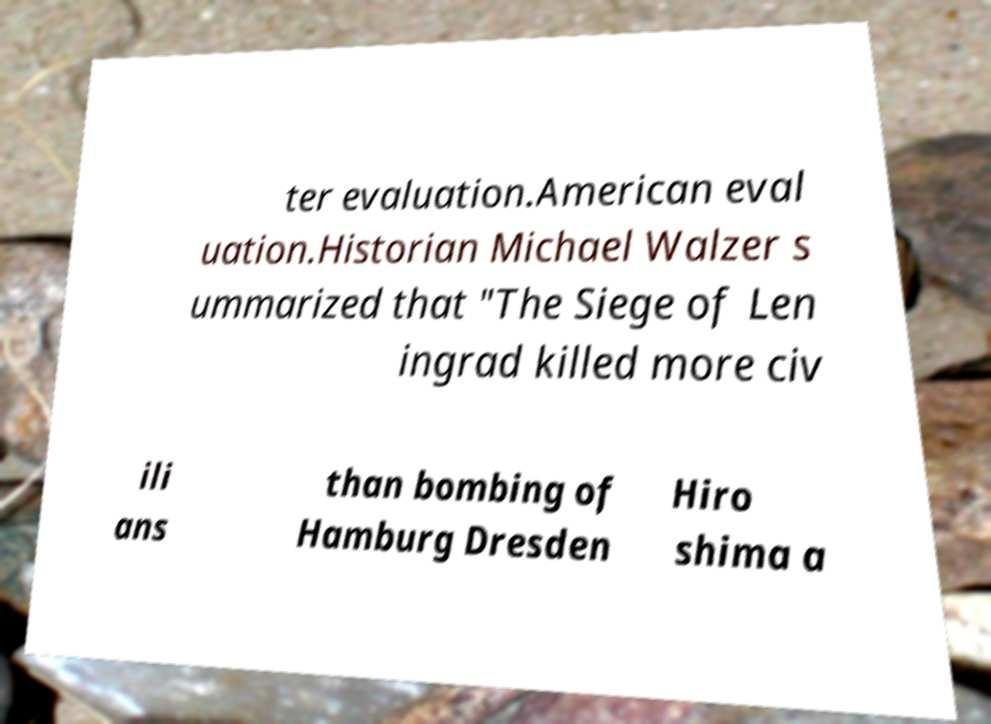Please identify and transcribe the text found in this image. ter evaluation.American eval uation.Historian Michael Walzer s ummarized that "The Siege of Len ingrad killed more civ ili ans than bombing of Hamburg Dresden Hiro shima a 